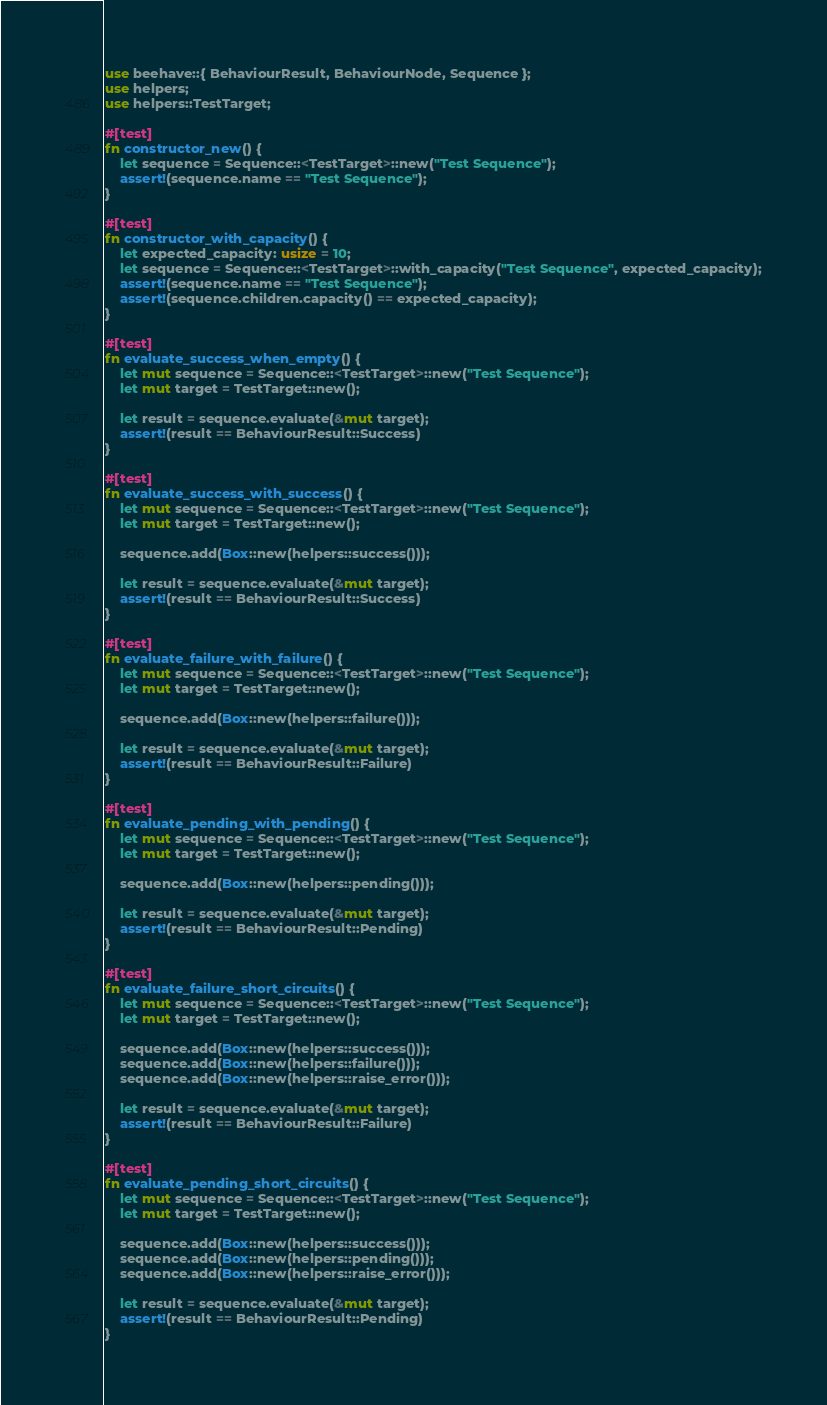Convert code to text. <code><loc_0><loc_0><loc_500><loc_500><_Rust_>use beehave::{ BehaviourResult, BehaviourNode, Sequence };
use helpers;
use helpers::TestTarget;

#[test]
fn constructor_new() {
    let sequence = Sequence::<TestTarget>::new("Test Sequence");
    assert!(sequence.name == "Test Sequence");
}

#[test]
fn constructor_with_capacity() {
    let expected_capacity: usize = 10;
    let sequence = Sequence::<TestTarget>::with_capacity("Test Sequence", expected_capacity);
    assert!(sequence.name == "Test Sequence");
    assert!(sequence.children.capacity() == expected_capacity);
}

#[test]
fn evaluate_success_when_empty() {
    let mut sequence = Sequence::<TestTarget>::new("Test Sequence");
    let mut target = TestTarget::new();

    let result = sequence.evaluate(&mut target);
    assert!(result == BehaviourResult::Success)
}

#[test]
fn evaluate_success_with_success() {
    let mut sequence = Sequence::<TestTarget>::new("Test Sequence");
    let mut target = TestTarget::new();

    sequence.add(Box::new(helpers::success()));

    let result = sequence.evaluate(&mut target);
    assert!(result == BehaviourResult::Success)
}

#[test]
fn evaluate_failure_with_failure() {
    let mut sequence = Sequence::<TestTarget>::new("Test Sequence");
    let mut target = TestTarget::new();

    sequence.add(Box::new(helpers::failure()));

    let result = sequence.evaluate(&mut target);
    assert!(result == BehaviourResult::Failure)
}

#[test]
fn evaluate_pending_with_pending() {
    let mut sequence = Sequence::<TestTarget>::new("Test Sequence");
    let mut target = TestTarget::new();

    sequence.add(Box::new(helpers::pending()));

    let result = sequence.evaluate(&mut target);
    assert!(result == BehaviourResult::Pending)
}

#[test]
fn evaluate_failure_short_circuits() {
    let mut sequence = Sequence::<TestTarget>::new("Test Sequence");
    let mut target = TestTarget::new();

    sequence.add(Box::new(helpers::success()));
    sequence.add(Box::new(helpers::failure()));
    sequence.add(Box::new(helpers::raise_error()));

    let result = sequence.evaluate(&mut target);
    assert!(result == BehaviourResult::Failure)
}

#[test]
fn evaluate_pending_short_circuits() {
    let mut sequence = Sequence::<TestTarget>::new("Test Sequence");
    let mut target = TestTarget::new();

    sequence.add(Box::new(helpers::success()));
    sequence.add(Box::new(helpers::pending()));
    sequence.add(Box::new(helpers::raise_error()));

    let result = sequence.evaluate(&mut target);
    assert!(result == BehaviourResult::Pending)
}
</code> 